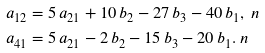<formula> <loc_0><loc_0><loc_500><loc_500>a _ { 1 2 } & = 5 \, a _ { 2 1 } + 1 0 \, b _ { 2 } - 2 7 \, b _ { 3 } - 4 0 \, b _ { 1 } , \ n \\ a _ { 4 1 } & = 5 \, a _ { 2 1 } - 2 \, b _ { 2 } - 1 5 \, b _ { 3 } - 2 0 \, b _ { 1 } . \ n</formula> 